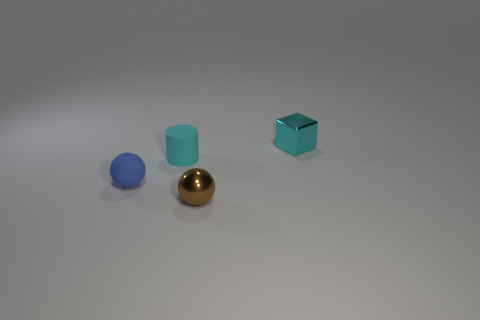Add 1 big blue matte objects. How many objects exist? 5 Subtract all blue spheres. How many spheres are left? 1 Subtract all cylinders. How many objects are left? 3 Subtract all blue spheres. How many green blocks are left? 0 Subtract all small blue matte objects. Subtract all tiny blue rubber objects. How many objects are left? 2 Add 1 brown objects. How many brown objects are left? 2 Add 4 tiny brown spheres. How many tiny brown spheres exist? 5 Subtract 0 cyan spheres. How many objects are left? 4 Subtract 1 spheres. How many spheres are left? 1 Subtract all blue balls. Subtract all cyan blocks. How many balls are left? 1 